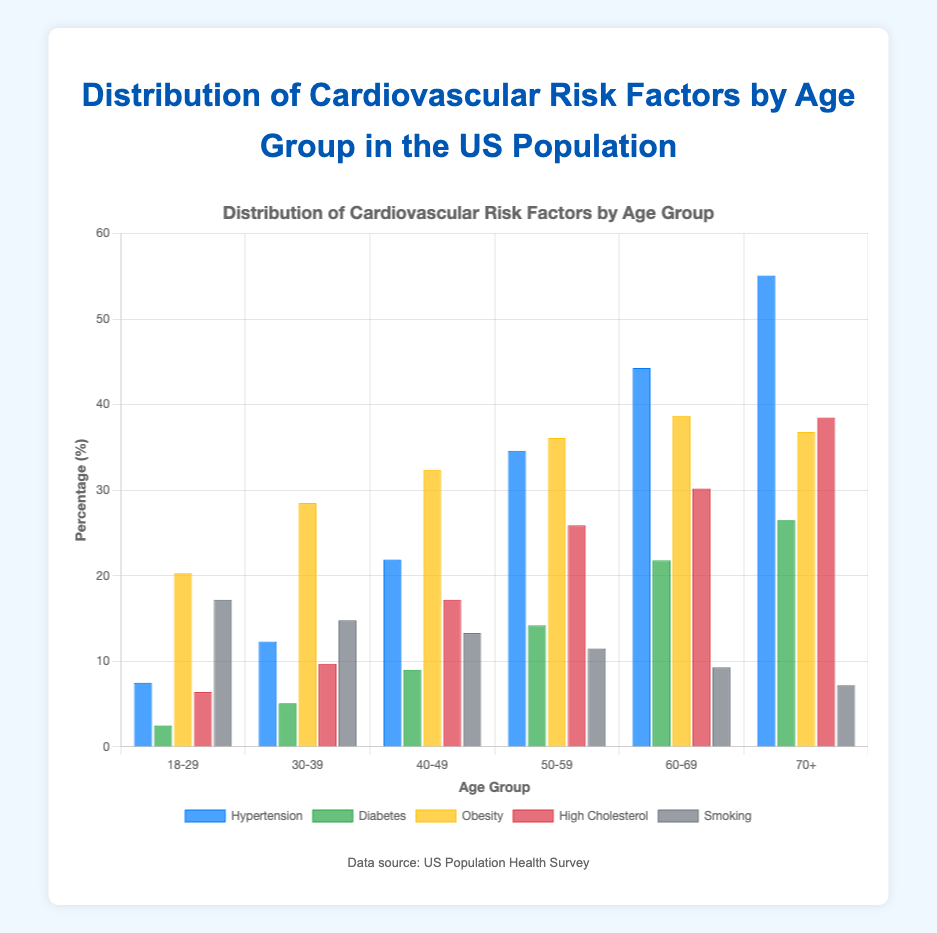Which age group has the highest percentage of hypertension? By examining the data, the "70+" age group has the highest hypertension percentage at 55.1%.
Answer: 70+ How does the obesity percentage change from the 18-29 age group to the 70+ age group? The obesity percentage increases from 20.3% in the 18-29 age group to 36.8% in the 70+ age group. The difference is 36.8% - 20.3% = 16.5%.
Answer: 16.5% What is the average percentage of diabetes across all age groups? Sum the diabetes percentages for all age groups: 2.5, 5.1, 9.0, 14.2, 21.8, and 26.5. The total is 79.1%. Divide by the number of age groups (6): 79.1 / 6 = 13.18%.
Answer: 13.18% In which age group is the smoking percentage the lowest? The lowest smoking percentage is seen in the "70+" age group at 7.2%.
Answer: 70+ What is the sum of the percentages of high cholesterol for the 50-59 and 60-69 age groups? Sum the percentages of high cholesterol for both age groups: 25.9% (50-59) + 30.2% (60-69) = 56.1%.
Answer: 56.1% Is the percentage of high cholesterol in the 40-49 age group higher than the percentage of diabetes in the 50-59 age group? The percentage of high cholesterol in the 40-49 age group is 17.2%, whereas the percentage of diabetes in the 50-59 age group is 14.2%. 17.2% > 14.2%.
Answer: yes Between the age groups 30-39 and 50-59, which has a higher percentage of obesity? The obesity percentage in the 30-39 age group is 28.5%, and in the 50-59 age group, it is 36.1%. 36.1% > 28.5%.
Answer: 50-59 What is the difference in the percentage of hypertension between the 40-49 and 60-69 age groups? The hypertension percentage for the 40-49 age group is 21.9%, and for the 60-69 age group, it is 44.3%. The difference is 44.3% - 21.9% = 22.4%.
Answer: 22.4% Among the age groups listed, which one shows the highest percentage of obesity, and what is that percentage? The "60-69" age group has the highest percentage of obesity at 38.7%.
Answer: 60-69, 38.7% 